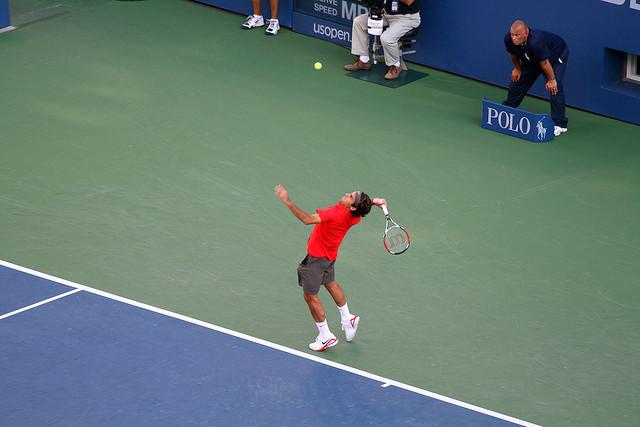Will the man hit the ball?
Quick response, please. Yes. Where can you buy a tennis racquet?
Concise answer only. Store. Is the man planning to hit the ball very hard?
Short answer required. Yes. Is the player celebrating?
Keep it brief. No. 